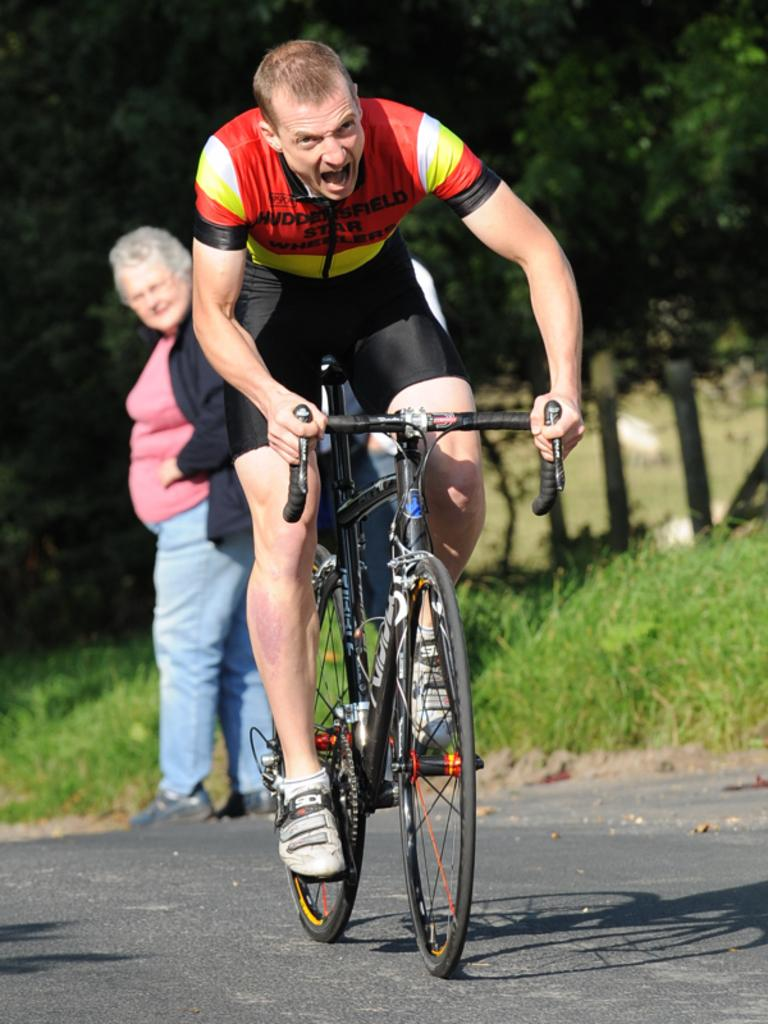What is the main subject of the image? There is a person riding a bicycle in the image. What are the other people in the image doing? There are people walking on the road in the image. What type of vegetation can be seen in the image? There is grass, plants, and trees in the image. What type of net is being used by the beginner in the image? There is no net or beginner present in the image; it features a person riding a bicycle and people walking on the road. How much of the bit is visible in the image? There is no bit present in the image; it does not involve any bit-related objects or activities. 